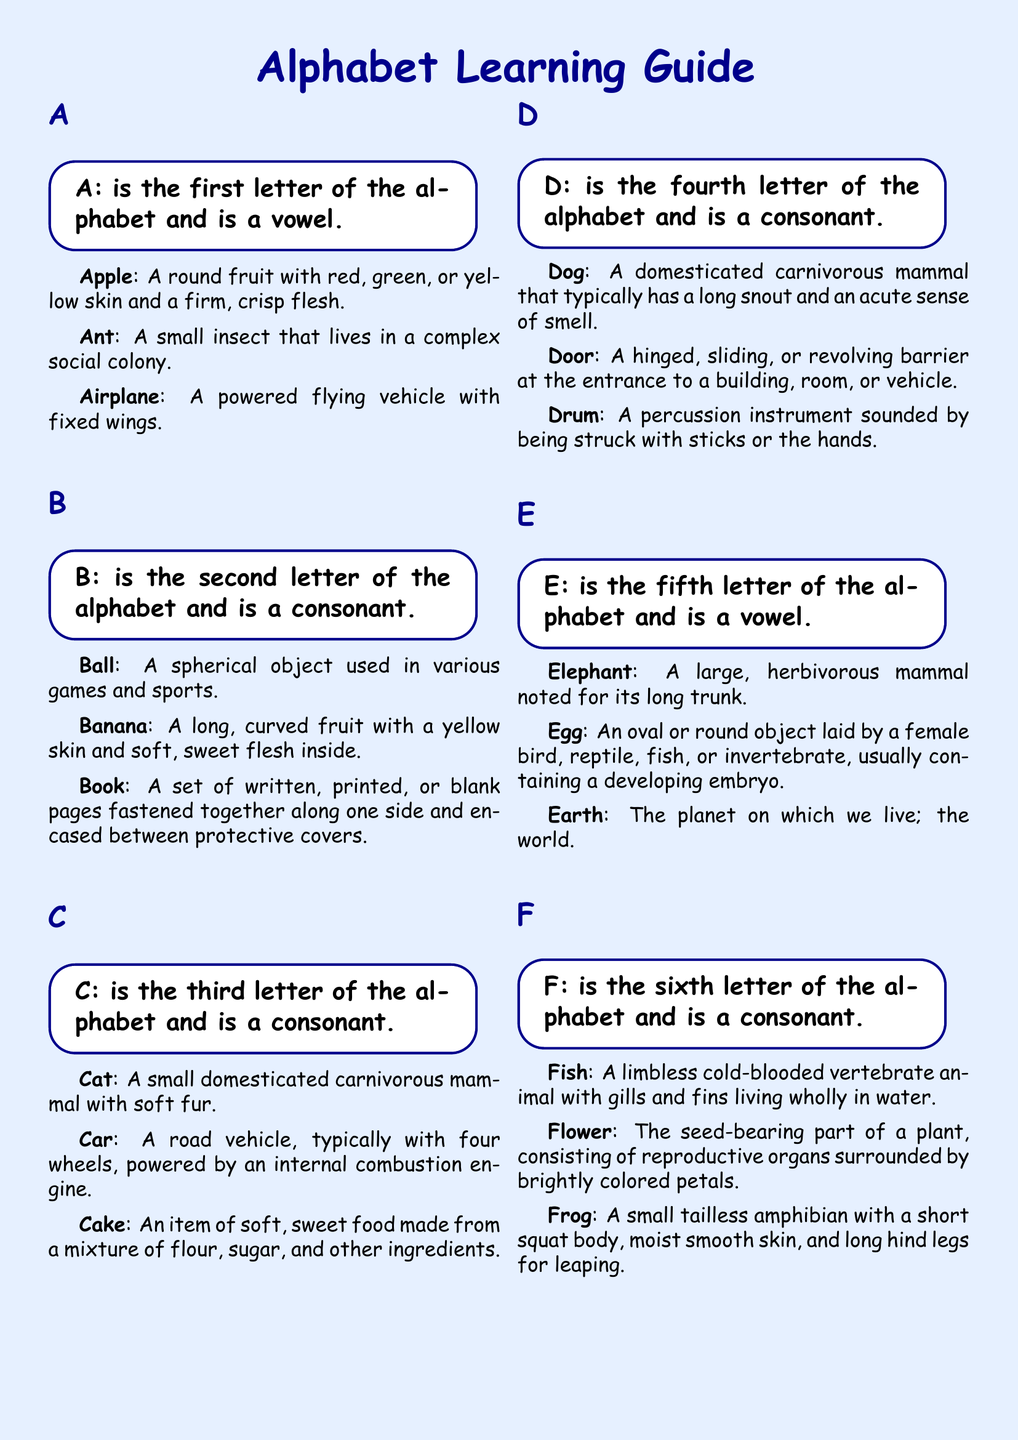What is the first letter of the alphabet? The letter "A" is specified as the first letter of the alphabet in the document.
Answer: A What fruit is associated with the letter A? An apple is defined as a round fruit with red, green, or yellow skin in the document.
Answer: Apple Which insect is mentioned under the letter A? The document mentions the ant as the small insect that lives in a colony.
Answer: Ant What is the fifth letter of the alphabet? The letter "E" is identified as the fifth letter of the alphabet in the document.
Answer: E What mammal is described under the letter E? The elephant, noted for its long trunk, is described under the letter E in the document.
Answer: Elephant What is the definition of ball? The document defines "Ball" as a spherical object used in various games and sports.
Answer: A spherical object used in various games and sports What does the letter C represent? The letter "C" is stated as the third letter of the alphabet and is a consonant.
Answer: C How many words are defined under the letter F? The document lists three words (Fish, Flower, Frog) defined under the letter F.
Answer: Three What is the definition of car? The definition from the document for "Car" is a road vehicle typically with four wheels.
Answer: A road vehicle, typically with four wheels 